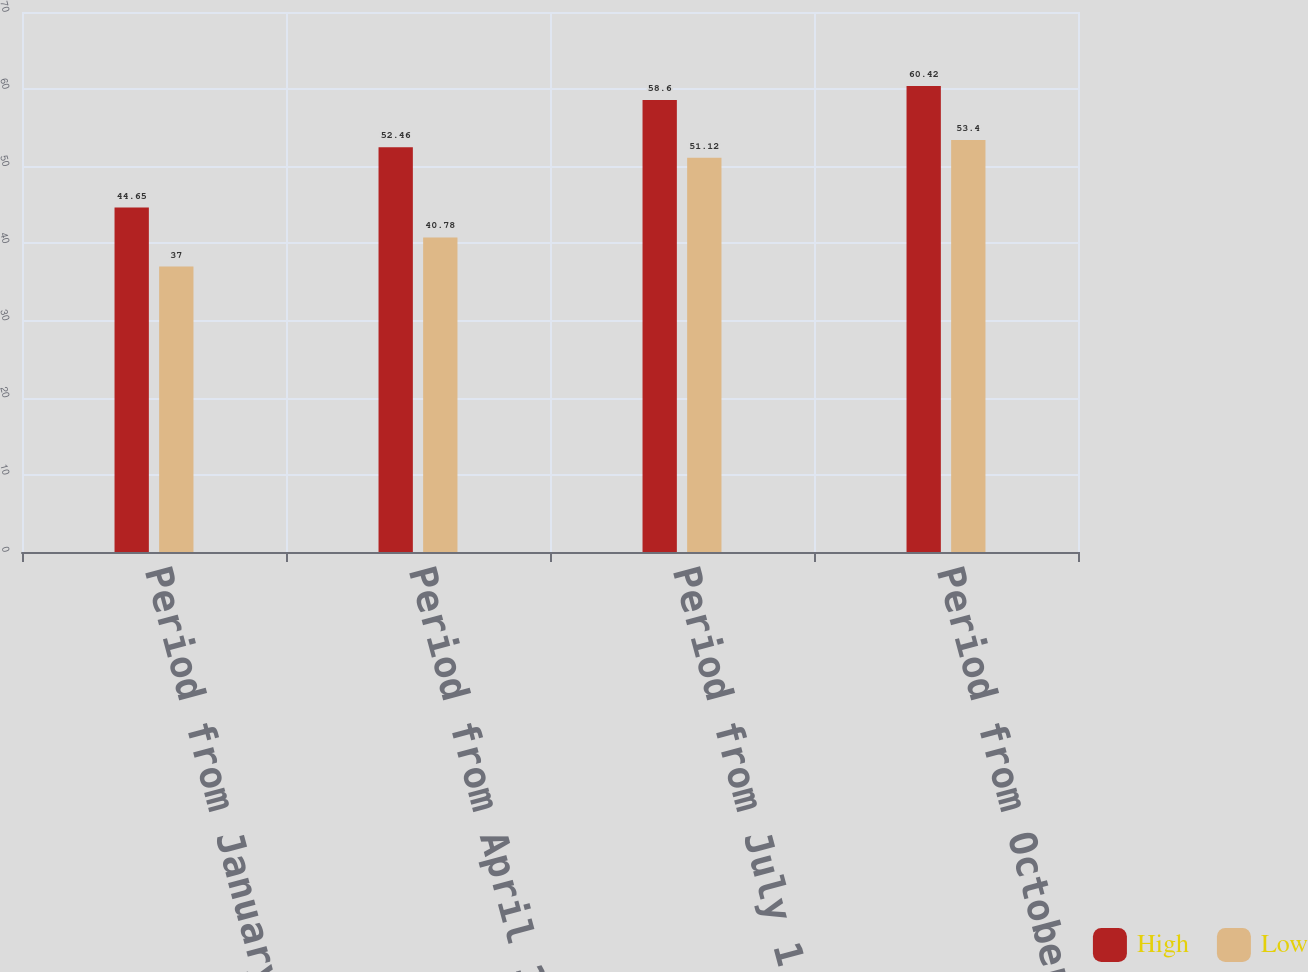Convert chart. <chart><loc_0><loc_0><loc_500><loc_500><stacked_bar_chart><ecel><fcel>Period from January 1 through<fcel>Period from April 1 through<fcel>Period from July 1 through<fcel>Period from October 1 through<nl><fcel>High<fcel>44.65<fcel>52.46<fcel>58.6<fcel>60.42<nl><fcel>Low<fcel>37<fcel>40.78<fcel>51.12<fcel>53.4<nl></chart> 